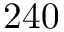<formula> <loc_0><loc_0><loc_500><loc_500>2 4 0</formula> 